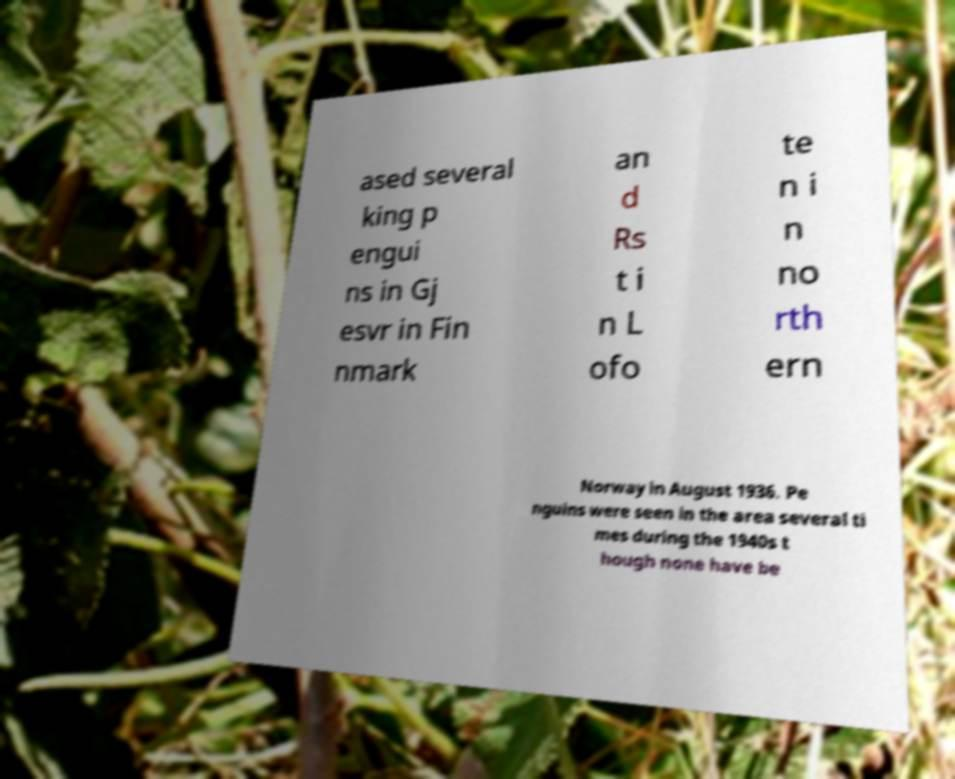I need the written content from this picture converted into text. Can you do that? ased several king p engui ns in Gj esvr in Fin nmark an d Rs t i n L ofo te n i n no rth ern Norway in August 1936. Pe nguins were seen in the area several ti mes during the 1940s t hough none have be 